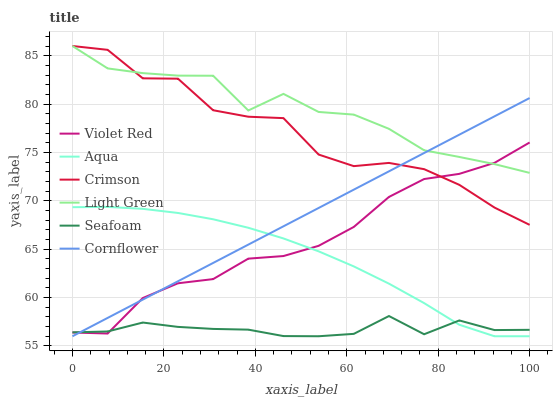Does Seafoam have the minimum area under the curve?
Answer yes or no. Yes. Does Light Green have the maximum area under the curve?
Answer yes or no. Yes. Does Violet Red have the minimum area under the curve?
Answer yes or no. No. Does Violet Red have the maximum area under the curve?
Answer yes or no. No. Is Cornflower the smoothest?
Answer yes or no. Yes. Is Crimson the roughest?
Answer yes or no. Yes. Is Violet Red the smoothest?
Answer yes or no. No. Is Violet Red the roughest?
Answer yes or no. No. Does Cornflower have the lowest value?
Answer yes or no. Yes. Does Violet Red have the lowest value?
Answer yes or no. No. Does Crimson have the highest value?
Answer yes or no. Yes. Does Violet Red have the highest value?
Answer yes or no. No. Is Seafoam less than Light Green?
Answer yes or no. Yes. Is Crimson greater than Aqua?
Answer yes or no. Yes. Does Aqua intersect Cornflower?
Answer yes or no. Yes. Is Aqua less than Cornflower?
Answer yes or no. No. Is Aqua greater than Cornflower?
Answer yes or no. No. Does Seafoam intersect Light Green?
Answer yes or no. No. 